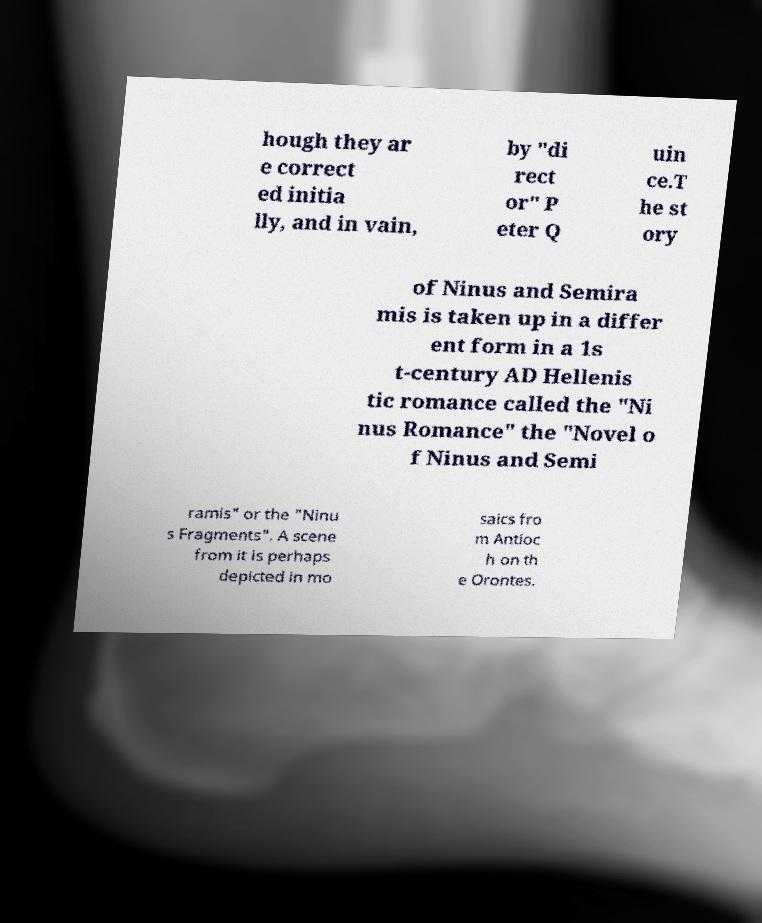Can you read and provide the text displayed in the image?This photo seems to have some interesting text. Can you extract and type it out for me? hough they ar e correct ed initia lly, and in vain, by "di rect or" P eter Q uin ce.T he st ory of Ninus and Semira mis is taken up in a differ ent form in a 1s t-century AD Hellenis tic romance called the "Ni nus Romance" the "Novel o f Ninus and Semi ramis" or the "Ninu s Fragments". A scene from it is perhaps depicted in mo saics fro m Antioc h on th e Orontes. 